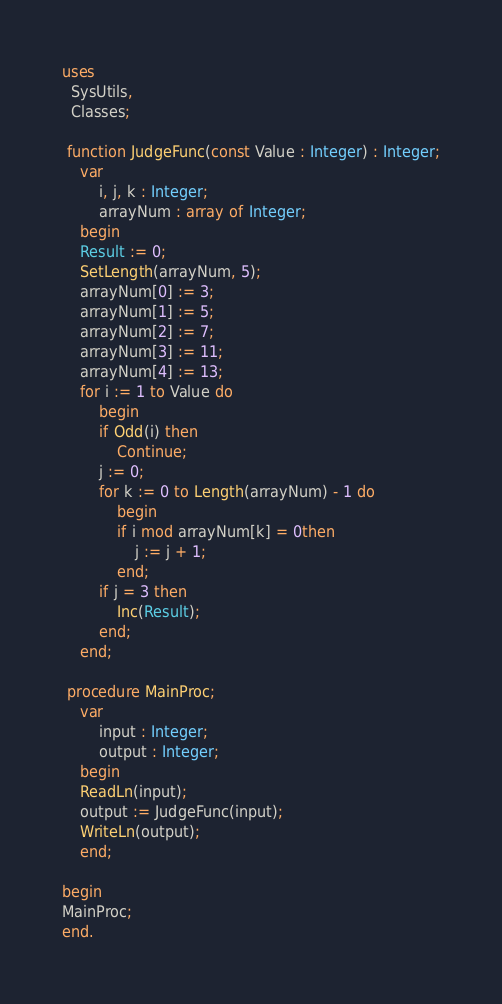<code> <loc_0><loc_0><loc_500><loc_500><_Pascal_>uses
  SysUtils,
  Classes;

 function JudgeFunc(const Value : Integer) : Integer;
	var
		i, j, k : Integer;
		arrayNum : array of Integer;
	begin
	Result := 0;
	SetLength(arrayNum, 5);
	arrayNum[0] := 3;
	arrayNum[1] := 5;
	arrayNum[2] := 7;
	arrayNum[3] := 11;
	arrayNum[4] := 13;
	for i := 1 to Value do
		begin
		if Odd(i) then
			Continue;
		j := 0;
		for k := 0 to Length(arrayNum) - 1 do
			begin
			if i mod arrayNum[k] = 0then
				j := j + 1;
			end;
		if j = 3 then
			Inc(Result);
		end;
	end;
  
 procedure MainProc;
	var
		input : Integer;
		output : Integer;
	begin
	ReadLn(input);
	output := JudgeFunc(input);
	WriteLn(output);
	end;
  
begin
MainProc;
end.</code> 